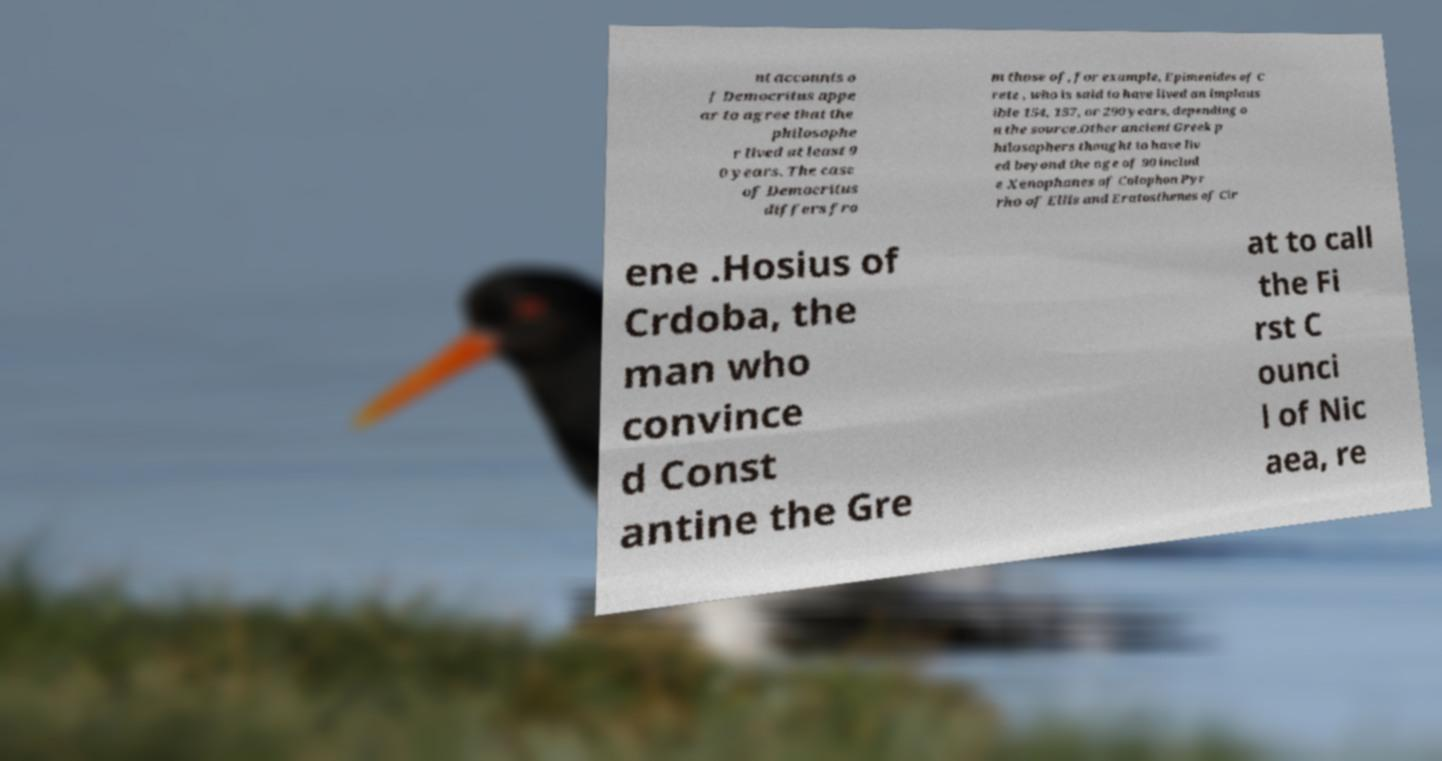Could you extract and type out the text from this image? nt accounts o f Democritus appe ar to agree that the philosophe r lived at least 9 0 years. The case of Democritus differs fro m those of, for example, Epimenides of C rete , who is said to have lived an implaus ible 154, 157, or 290 years, depending o n the source.Other ancient Greek p hilosophers thought to have liv ed beyond the age of 90 includ e Xenophanes of Colophon Pyr rho of Ellis and Eratosthenes of Cir ene .Hosius of Crdoba, the man who convince d Const antine the Gre at to call the Fi rst C ounci l of Nic aea, re 